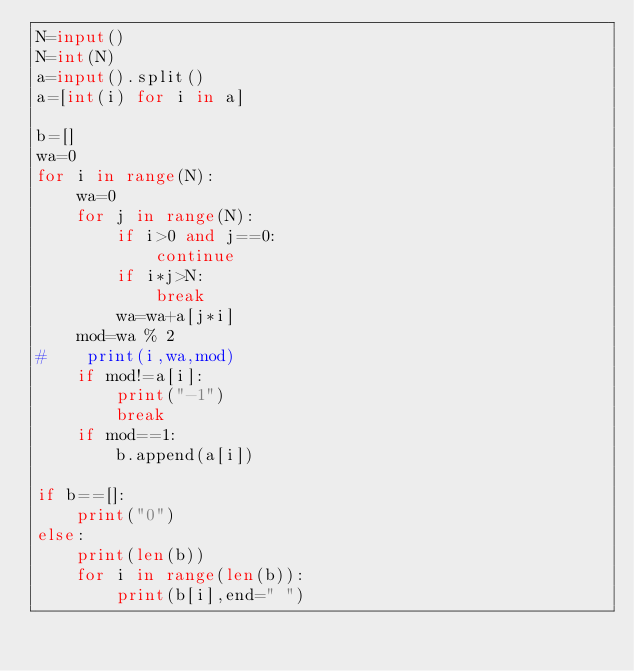<code> <loc_0><loc_0><loc_500><loc_500><_Python_>N=input()
N=int(N)
a=input().split()
a=[int(i) for i in a]

b=[]
wa=0
for i in range(N):
    wa=0
    for j in range(N):
        if i>0 and j==0:
            continue
        if i*j>N:
            break
        wa=wa+a[j*i]
    mod=wa % 2
#    print(i,wa,mod)
    if mod!=a[i]:
        print("-1")
        break
    if mod==1:
        b.append(a[i])

if b==[]:
    print("0")
else:
    print(len(b))
    for i in range(len(b)):
        print(b[i],end=" ")    
</code> 